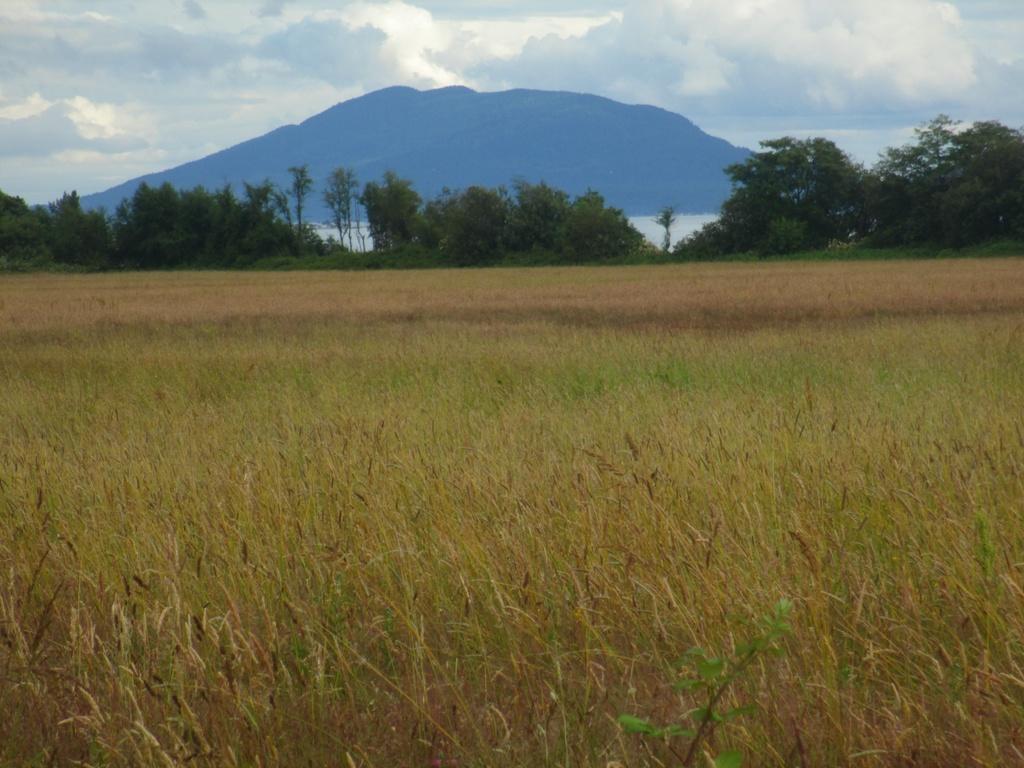Please provide a concise description of this image. In this image we can see some trees, grass, water, mountains and plants, in the background, we can see the sky with clouds. 